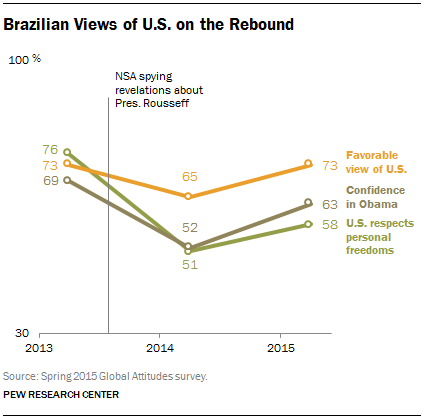Identify some key points in this picture. The median value of the orange graph is 73. The rightmost value in the "orange" graph is 73. 